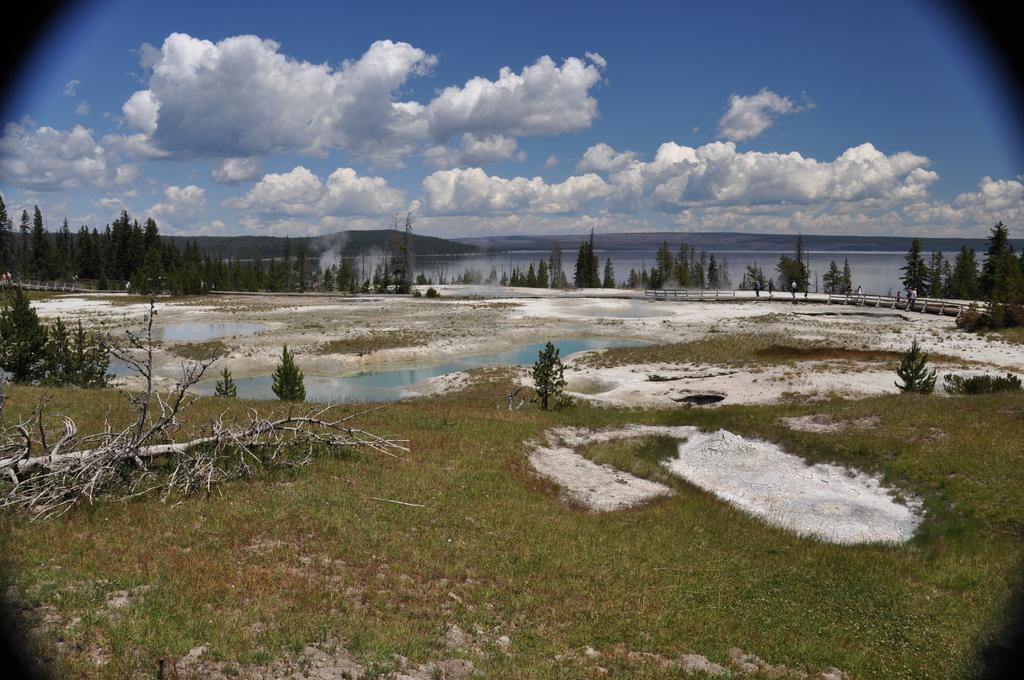Please provide a concise description of this image. In the image we can see there is ground covered with grass and there are lot of trees. Behind there is water on the ground and there is a cloudy sky. 